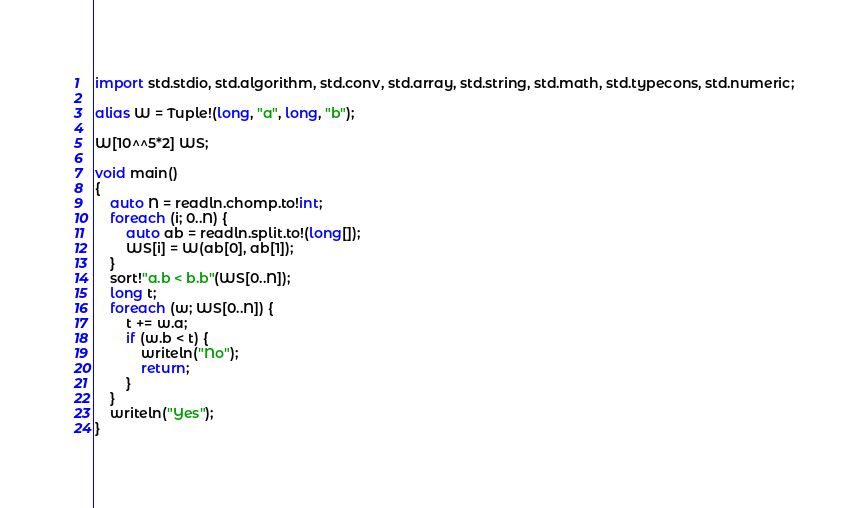Convert code to text. <code><loc_0><loc_0><loc_500><loc_500><_D_>import std.stdio, std.algorithm, std.conv, std.array, std.string, std.math, std.typecons, std.numeric;

alias W = Tuple!(long, "a", long, "b");

W[10^^5*2] WS;

void main()
{
    auto N = readln.chomp.to!int;
    foreach (i; 0..N) {
        auto ab = readln.split.to!(long[]);
        WS[i] = W(ab[0], ab[1]);
    }
    sort!"a.b < b.b"(WS[0..N]);
    long t;
    foreach (w; WS[0..N]) {
        t += w.a;
        if (w.b < t) {
            writeln("No");
            return;
        }
    }
    writeln("Yes");
}</code> 